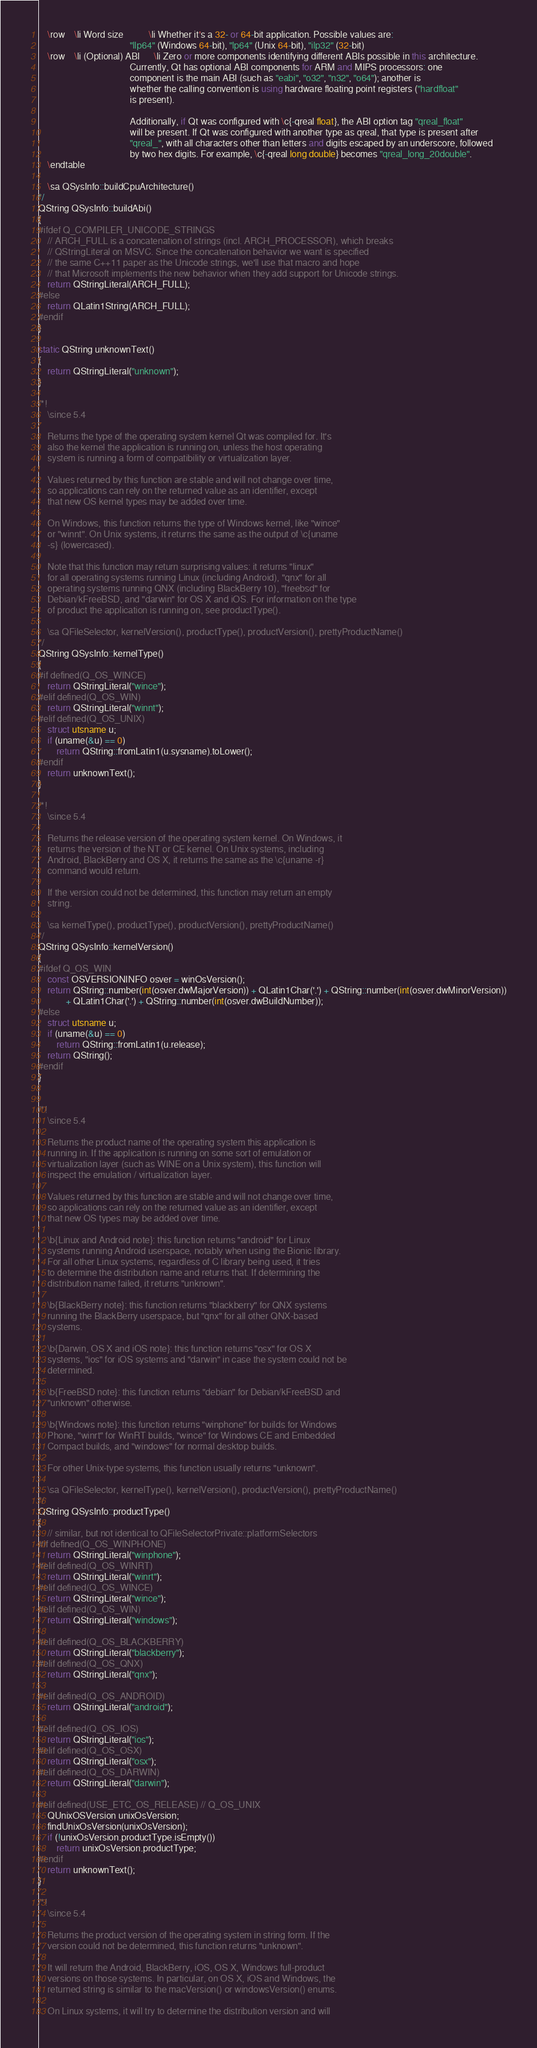Convert code to text. <code><loc_0><loc_0><loc_500><loc_500><_C++_>    \row    \li Word size           \li Whether it's a 32- or 64-bit application. Possible values are:
                                        "llp64" (Windows 64-bit), "lp64" (Unix 64-bit), "ilp32" (32-bit)
    \row    \li (Optional) ABI      \li Zero or more components identifying different ABIs possible in this architecture.
                                        Currently, Qt has optional ABI components for ARM and MIPS processors: one
                                        component is the main ABI (such as "eabi", "o32", "n32", "o64"); another is
                                        whether the calling convention is using hardware floating point registers ("hardfloat"
                                        is present).

                                        Additionally, if Qt was configured with \c{-qreal float}, the ABI option tag "qreal_float"
                                        will be present. If Qt was configured with another type as qreal, that type is present after
                                        "qreal_", with all characters other than letters and digits escaped by an underscore, followed
                                        by two hex digits. For example, \c{-qreal long double} becomes "qreal_long_20double".
    \endtable

    \sa QSysInfo::buildCpuArchitecture()
*/
QString QSysInfo::buildAbi()
{
#ifdef Q_COMPILER_UNICODE_STRINGS
    // ARCH_FULL is a concatenation of strings (incl. ARCH_PROCESSOR), which breaks
    // QStringLiteral on MSVC. Since the concatenation behavior we want is specified
    // the same C++11 paper as the Unicode strings, we'll use that macro and hope
    // that Microsoft implements the new behavior when they add support for Unicode strings.
    return QStringLiteral(ARCH_FULL);
#else
    return QLatin1String(ARCH_FULL);
#endif
}

static QString unknownText()
{
    return QStringLiteral("unknown");
}

/*!
    \since 5.4

    Returns the type of the operating system kernel Qt was compiled for. It's
    also the kernel the application is running on, unless the host operating
    system is running a form of compatibility or virtualization layer.

    Values returned by this function are stable and will not change over time,
    so applications can rely on the returned value as an identifier, except
    that new OS kernel types may be added over time.

    On Windows, this function returns the type of Windows kernel, like "wince"
    or "winnt". On Unix systems, it returns the same as the output of \c{uname
    -s} (lowercased).

    Note that this function may return surprising values: it returns "linux"
    for all operating systems running Linux (including Android), "qnx" for all
    operating systems running QNX (including BlackBerry 10), "freebsd" for
    Debian/kFreeBSD, and "darwin" for OS X and iOS. For information on the type
    of product the application is running on, see productType().

    \sa QFileSelector, kernelVersion(), productType(), productVersion(), prettyProductName()
*/
QString QSysInfo::kernelType()
{
#if defined(Q_OS_WINCE)
    return QStringLiteral("wince");
#elif defined(Q_OS_WIN)
    return QStringLiteral("winnt");
#elif defined(Q_OS_UNIX)
    struct utsname u;
    if (uname(&u) == 0)
        return QString::fromLatin1(u.sysname).toLower();
#endif
    return unknownText();
}

/*!
    \since 5.4

    Returns the release version of the operating system kernel. On Windows, it
    returns the version of the NT or CE kernel. On Unix systems, including
    Android, BlackBerry and OS X, it returns the same as the \c{uname -r}
    command would return.

    If the version could not be determined, this function may return an empty
    string.

    \sa kernelType(), productType(), productVersion(), prettyProductName()
*/
QString QSysInfo::kernelVersion()
{
#ifdef Q_OS_WIN
    const OSVERSIONINFO osver = winOsVersion();
    return QString::number(int(osver.dwMajorVersion)) + QLatin1Char('.') + QString::number(int(osver.dwMinorVersion))
            + QLatin1Char('.') + QString::number(int(osver.dwBuildNumber));
#else
    struct utsname u;
    if (uname(&u) == 0)
        return QString::fromLatin1(u.release);
    return QString();
#endif
}


/*!
    \since 5.4

    Returns the product name of the operating system this application is
    running in. If the application is running on some sort of emulation or
    virtualization layer (such as WINE on a Unix system), this function will
    inspect the emulation / virtualization layer.

    Values returned by this function are stable and will not change over time,
    so applications can rely on the returned value as an identifier, except
    that new OS types may be added over time.

    \b{Linux and Android note}: this function returns "android" for Linux
    systems running Android userspace, notably when using the Bionic library.
    For all other Linux systems, regardless of C library being used, it tries
    to determine the distribution name and returns that. If determining the
    distribution name failed, it returns "unknown".

    \b{BlackBerry note}: this function returns "blackberry" for QNX systems
    running the BlackBerry userspace, but "qnx" for all other QNX-based
    systems.

    \b{Darwin, OS X and iOS note}: this function returns "osx" for OS X
    systems, "ios" for iOS systems and "darwin" in case the system could not be
    determined.

    \b{FreeBSD note}: this function returns "debian" for Debian/kFreeBSD and
    "unknown" otherwise.

    \b{Windows note}: this function returns "winphone" for builds for Windows
    Phone, "winrt" for WinRT builds, "wince" for Windows CE and Embedded
    Compact builds, and "windows" for normal desktop builds.

    For other Unix-type systems, this function usually returns "unknown".

    \sa QFileSelector, kernelType(), kernelVersion(), productVersion(), prettyProductName()
*/
QString QSysInfo::productType()
{
    // similar, but not identical to QFileSelectorPrivate::platformSelectors
#if defined(Q_OS_WINPHONE)
    return QStringLiteral("winphone");
#elif defined(Q_OS_WINRT)
    return QStringLiteral("winrt");
#elif defined(Q_OS_WINCE)
    return QStringLiteral("wince");
#elif defined(Q_OS_WIN)
    return QStringLiteral("windows");

#elif defined(Q_OS_BLACKBERRY)
    return QStringLiteral("blackberry");
#elif defined(Q_OS_QNX)
    return QStringLiteral("qnx");

#elif defined(Q_OS_ANDROID)
    return QStringLiteral("android");

#elif defined(Q_OS_IOS)
    return QStringLiteral("ios");
#elif defined(Q_OS_OSX)
    return QStringLiteral("osx");
#elif defined(Q_OS_DARWIN)
    return QStringLiteral("darwin");

#elif defined(USE_ETC_OS_RELEASE) // Q_OS_UNIX
    QUnixOSVersion unixOsVersion;
    findUnixOsVersion(unixOsVersion);
    if (!unixOsVersion.productType.isEmpty())
        return unixOsVersion.productType;
#endif
    return unknownText();
}

/*!
    \since 5.4

    Returns the product version of the operating system in string form. If the
    version could not be determined, this function returns "unknown".

    It will return the Android, BlackBerry, iOS, OS X, Windows full-product
    versions on those systems. In particular, on OS X, iOS and Windows, the
    returned string is similar to the macVersion() or windowsVersion() enums.

    On Linux systems, it will try to determine the distribution version and will</code> 